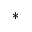<formula> <loc_0><loc_0><loc_500><loc_500>*</formula> 